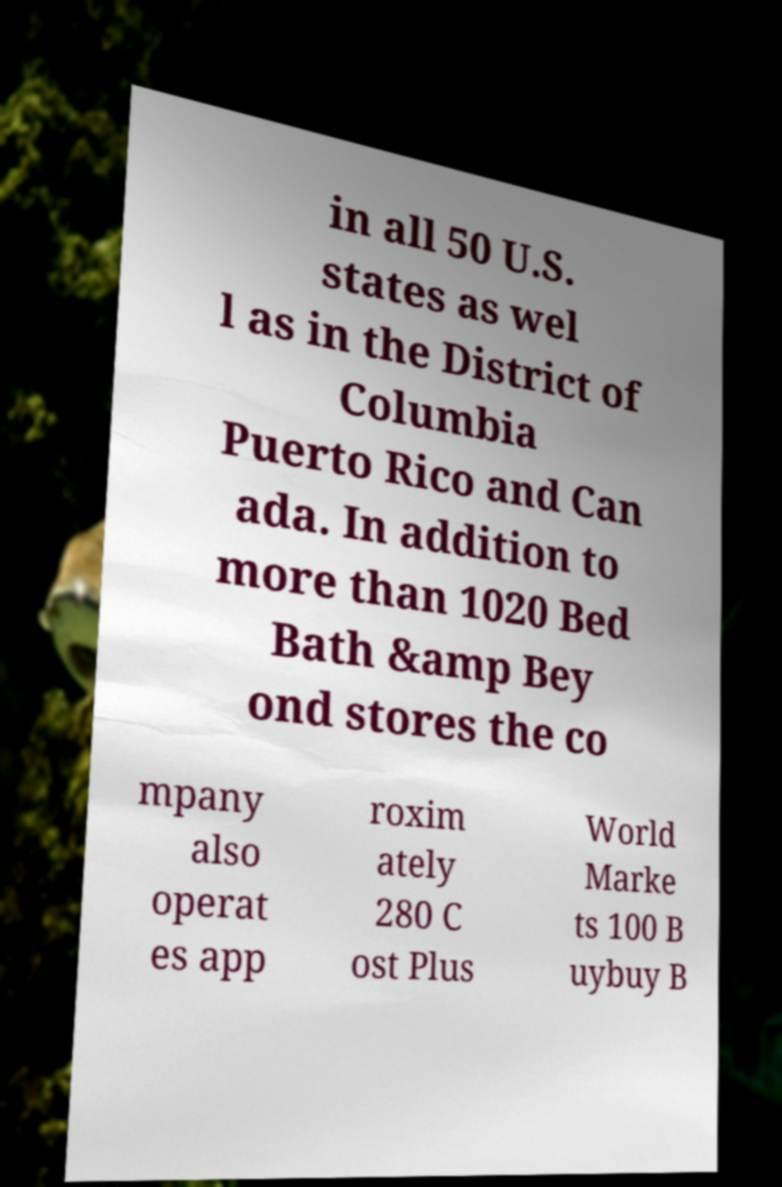There's text embedded in this image that I need extracted. Can you transcribe it verbatim? in all 50 U.S. states as wel l as in the District of Columbia Puerto Rico and Can ada. In addition to more than 1020 Bed Bath &amp Bey ond stores the co mpany also operat es app roxim ately 280 C ost Plus World Marke ts 100 B uybuy B 